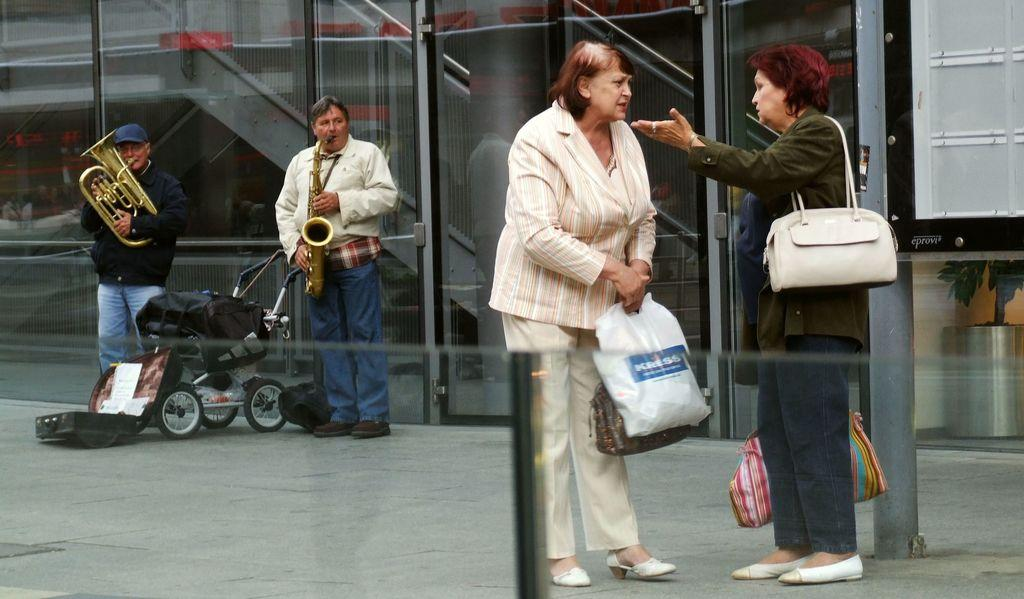What is the main structure visible in the image? There is a building in the image. How many people are present in the image? There are four people in the image. What are two of the people doing in the image? Two of the people are holding musical instruments. What is the woman holding in the image? A: A woman is holding a handbag in the image. What type of leather can be seen on the nut in the image? There is no leather or nut present in the image. How does the woman kick the musical instrument in the image? The woman is not kicking any musical instrument in the image; she is holding a handbag. 